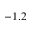<formula> <loc_0><loc_0><loc_500><loc_500>- 1 . 2</formula> 